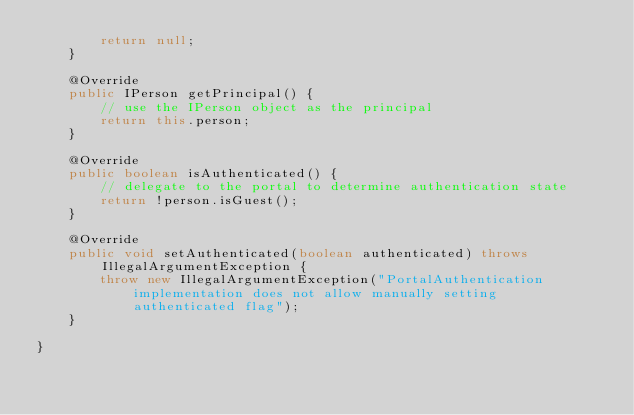Convert code to text. <code><loc_0><loc_0><loc_500><loc_500><_Java_>        return null;
    }

    @Override
    public IPerson getPrincipal() {
        // use the IPerson object as the principal
        return this.person;
    }

    @Override
    public boolean isAuthenticated() {
        // delegate to the portal to determine authentication state
        return !person.isGuest();
    }

    @Override
    public void setAuthenticated(boolean authenticated) throws IllegalArgumentException {
        throw new IllegalArgumentException("PortalAuthentication implementation does not allow manually setting authenticated flag");
    }

}
</code> 